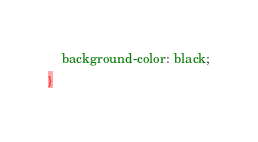<code> <loc_0><loc_0><loc_500><loc_500><_CSS_>    background-color: black;
}</code> 